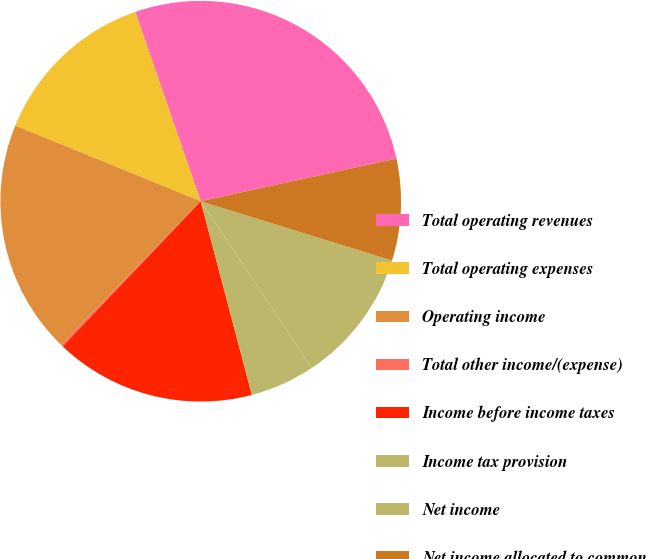Convert chart. <chart><loc_0><loc_0><loc_500><loc_500><pie_chart><fcel>Total operating revenues<fcel>Total operating expenses<fcel>Operating income<fcel>Total other income/(expense)<fcel>Income before income taxes<fcel>Income tax provision<fcel>Net income<fcel>Net income allocated to common<nl><fcel>26.88%<fcel>13.54%<fcel>18.88%<fcel>0.18%<fcel>16.21%<fcel>5.23%<fcel>10.87%<fcel>8.2%<nl></chart> 